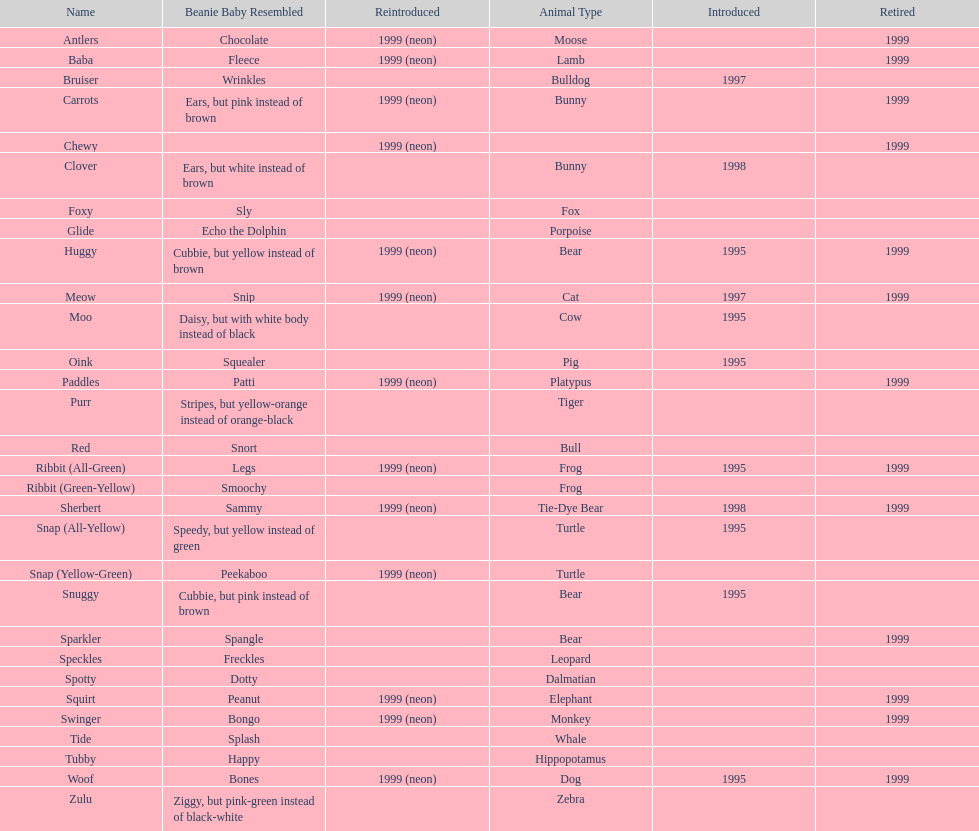Parse the full table. {'header': ['Name', 'Beanie Baby Resembled', 'Reintroduced', 'Animal Type', 'Introduced', 'Retired'], 'rows': [['Antlers', 'Chocolate', '1999 (neon)', 'Moose', '', '1999'], ['Baba', 'Fleece', '1999 (neon)', 'Lamb', '', '1999'], ['Bruiser', 'Wrinkles', '', 'Bulldog', '1997', ''], ['Carrots', 'Ears, but pink instead of brown', '1999 (neon)', 'Bunny', '', '1999'], ['Chewy', '', '1999 (neon)', '', '', '1999'], ['Clover', 'Ears, but white instead of brown', '', 'Bunny', '1998', ''], ['Foxy', 'Sly', '', 'Fox', '', ''], ['Glide', 'Echo the Dolphin', '', 'Porpoise', '', ''], ['Huggy', 'Cubbie, but yellow instead of brown', '1999 (neon)', 'Bear', '1995', '1999'], ['Meow', 'Snip', '1999 (neon)', 'Cat', '1997', '1999'], ['Moo', 'Daisy, but with white body instead of black', '', 'Cow', '1995', ''], ['Oink', 'Squealer', '', 'Pig', '1995', ''], ['Paddles', 'Patti', '1999 (neon)', 'Platypus', '', '1999'], ['Purr', 'Stripes, but yellow-orange instead of orange-black', '', 'Tiger', '', ''], ['Red', 'Snort', '', 'Bull', '', ''], ['Ribbit (All-Green)', 'Legs', '1999 (neon)', 'Frog', '1995', '1999'], ['Ribbit (Green-Yellow)', 'Smoochy', '', 'Frog', '', ''], ['Sherbert', 'Sammy', '1999 (neon)', 'Tie-Dye Bear', '1998', '1999'], ['Snap (All-Yellow)', 'Speedy, but yellow instead of green', '', 'Turtle', '1995', ''], ['Snap (Yellow-Green)', 'Peekaboo', '1999 (neon)', 'Turtle', '', ''], ['Snuggy', 'Cubbie, but pink instead of brown', '', 'Bear', '1995', ''], ['Sparkler', 'Spangle', '', 'Bear', '', '1999'], ['Speckles', 'Freckles', '', 'Leopard', '', ''], ['Spotty', 'Dotty', '', 'Dalmatian', '', ''], ['Squirt', 'Peanut', '1999 (neon)', 'Elephant', '', '1999'], ['Swinger', 'Bongo', '1999 (neon)', 'Monkey', '', '1999'], ['Tide', 'Splash', '', 'Whale', '', ''], ['Tubby', 'Happy', '', 'Hippopotamus', '', ''], ['Woof', 'Bones', '1999 (neon)', 'Dog', '1995', '1999'], ['Zulu', 'Ziggy, but pink-green instead of black-white', '', 'Zebra', '', '']]} Which animal type has the most pillow pals? Bear. 